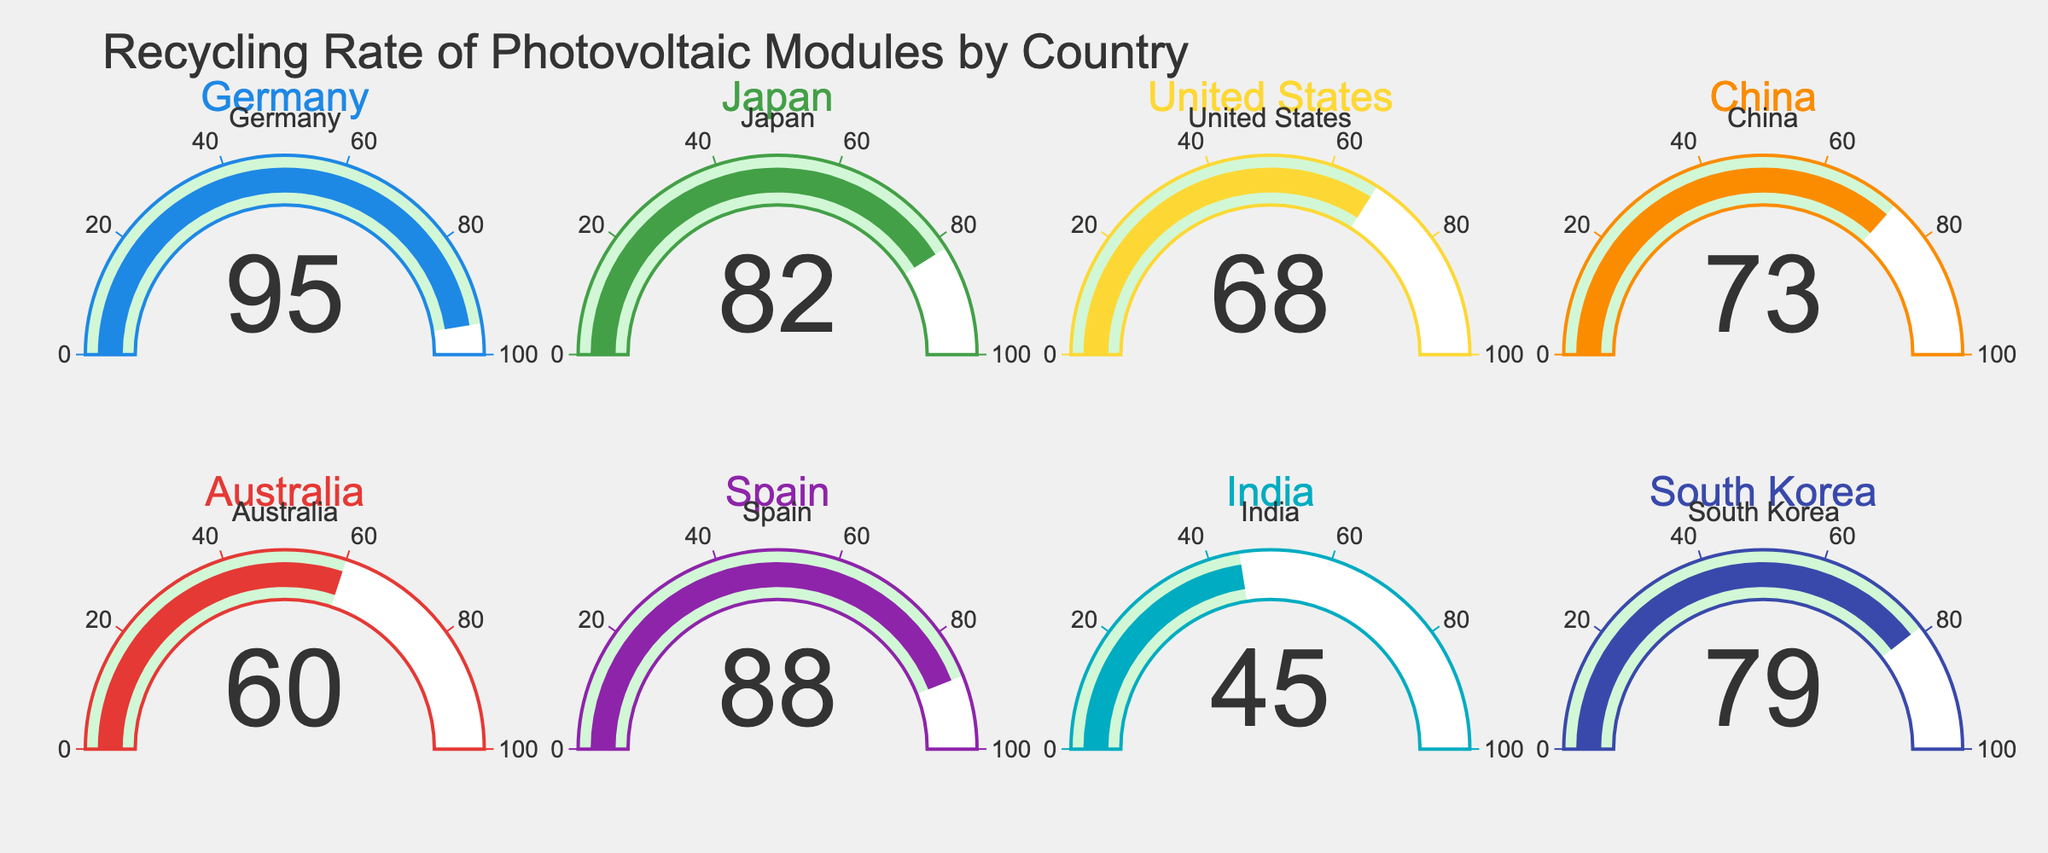What's the highest recycling rate shown in the figure? The highest recycling rate can be determined by observing the highest number displayed on the gauges. Germany's gauge shows a recycling rate of 95%, which is the highest among all presented countries.
Answer: 95% Which country has the lowest recycling rate? To identify the country with the lowest recycling rate, one needs to find the smallest number displayed on the gauges. India's gauge indicates a recycling rate of 45%, which is the lowest.
Answer: India What's the average recycling rate of all countries combined? Sum up all the recycling rates and then divide by the number of countries. The sum is 95 + 82 + 68 + 73 + 60 + 88 + 45 + 79 = 590. The number of countries is 8. Hence, the average recycling rate is 590 / 8 ≈ 73.75%.
Answer: 73.75% How many countries have a recycling rate greater than 70%? Count the number of gauges that show a recycling rate exceeding 70%. The countries that meet this criterion are Germany (95), Japan (82), Spain (88), South Korea (79), China (73). Accordingly, there are 5 such countries.
Answer: 5 Which countries have a recycling rate below 75%? Identify the countries whose gauges indicate a recycling rate under 75%. The relevant countries are United States (68), China (73), Australia (60), India (45).
Answer: United States, China, Australia, India What is the difference between the highest and lowest recycling rates? Subtract the lowest recycling rate from the highest: 95% (Germany) - 45% (India) = 50%.
Answer: 50% Compare the recycling rate of Japan and the United States. Which country has a higher rate? Compare the numbers shown on their respective gauges. Japan's recycling rate is 82%, while the United States has 68%. Hence, Japan has a higher recycling rate.
Answer: Japan Among the countries listed, which ones have a recycling rate between 60% and 80%? Identify the gauges that show a recycling rate within the given range. The countries are Japan (82, which doesn't qualify), United States (68), China (73), Australia (60), and South Korea (79). Hence, United States, China, and South Korea are the ones to consider.
Answer: United States, China, South Korea 